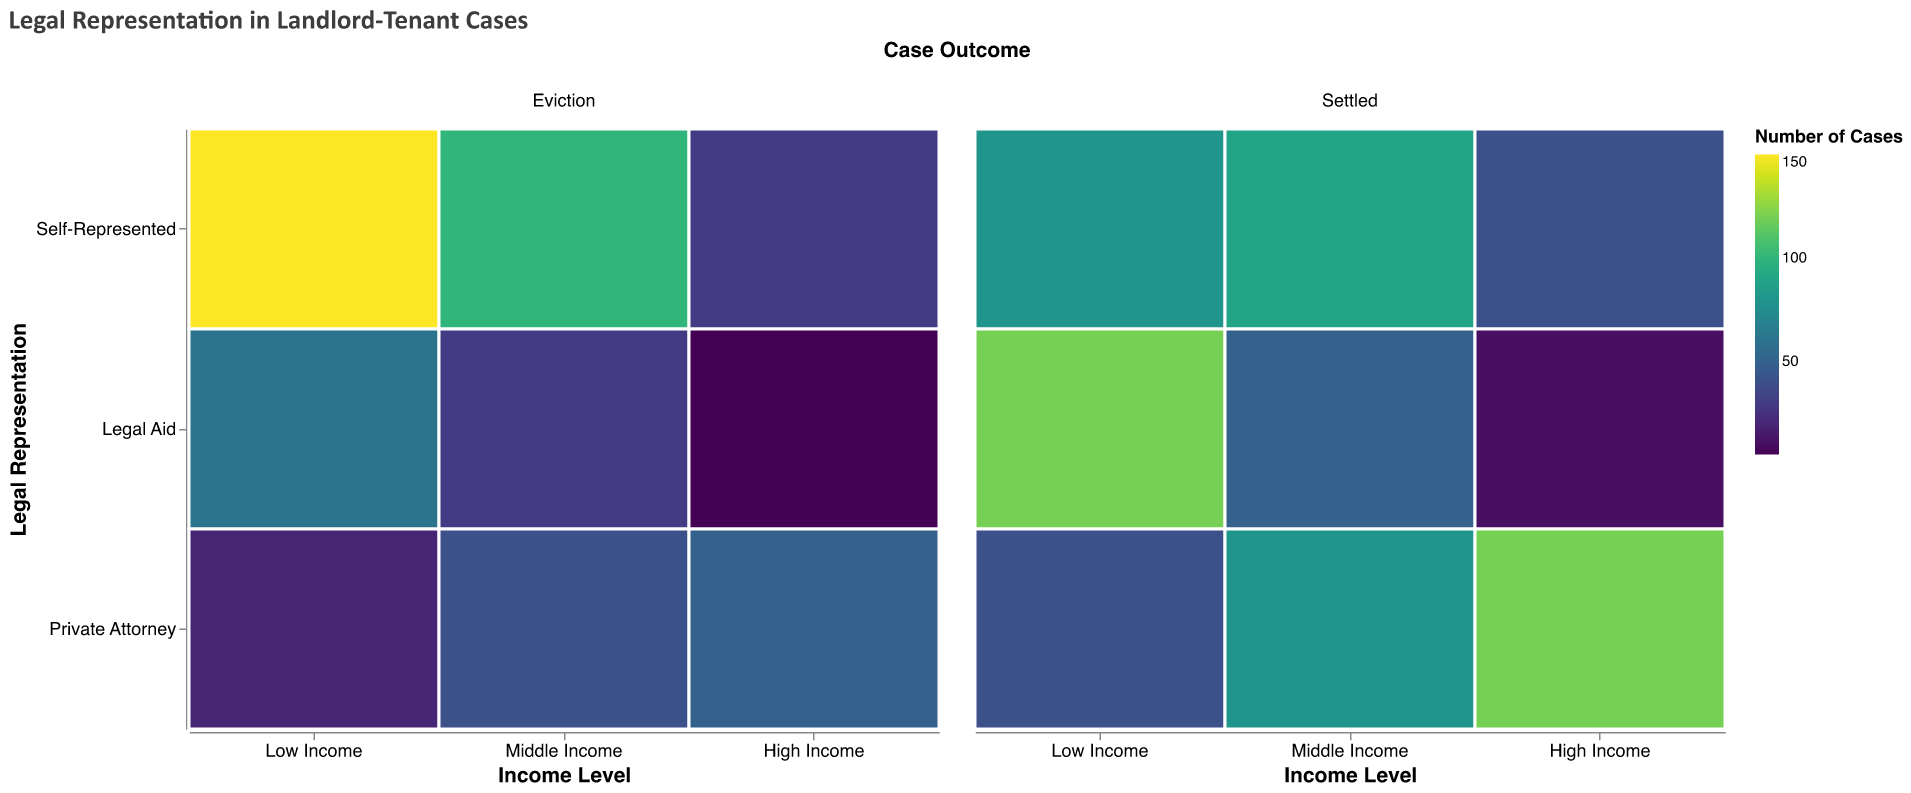What is the title of the figure? The title of the figure appears at the top and summarizes the content.
Answer: Legal Representation in Landlord-Tenant Cases Which income level has the highest number of eviction cases when self-represented? To find the answer, look at the "Eviction" column and "Self-Represented" row for each income level. The "Low Income" category has the highest count of 150.
Answer: Low Income How many total cases are there for low-income individuals who had legal aid representation? Add the counts for both eviction and settled cases under "Legal Aid" for "Low Income." These are 60 (eviction) and 120 (settled). Summing these gives 180.
Answer: 180 Which representation type has the fewest eviction cases for high-income individuals? Compare the counts in the "Eviction" column for "High Income" across all representation types. "Legal Aid" has the lowest count with 5 cases.
Answer: Legal Aid What is the difference in settlement cases between low-income and high-income individuals with a private attorney? Subtract the number of "Settled" cases for "High Income" (120) from Low Income (40). The difference is 80.
Answer: 80 Which group has the highest number of settled cases? Compare all values in the "Settled" column across all categories. High-income individuals represented by a private attorney have the highest count with 120.
Answer: High Income, Private Attorney In middle-income cases, are there more settled cases for self-represented individuals or those with a private attorney? Compare the "Settled" cases for "Self-Represented" (90) and "Private Attorney" (80) for middle-income individuals. Self-represented has more cases.
Answer: Self-represented Which income level and legal representation combination has the least number of cases overall? Calculate the total number of cases for each combination. "High Income" with "Legal Aid" has the fewest cases: 5 (Eviction) + 10 (Settled) = 15.
Answer: High Income, Legal Aid What proportion of eviction cases in low-income individuals were self-represented? Calculate the proportion by dividing the number of self-represented eviction cases (150) by the total eviction cases for low income individuals (150 + 60 + 20 = 230). The proportion is 150/230.
Answer: 65.2% Which income level has the most balanced outcome (almost equal eviction and settled cases) for self-represented individuals? Compare the "Eviction" and "Settled" counts within each income level for the "Self-Represented" group. Middle Income has 100 (Eviction) and 90 (Settled), which is the most balanced.
Answer: Middle Income 